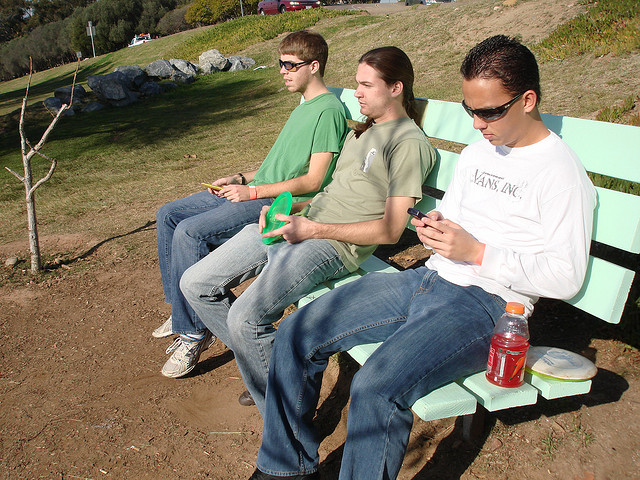Identify the text displayed in this image. VANS, INC. 